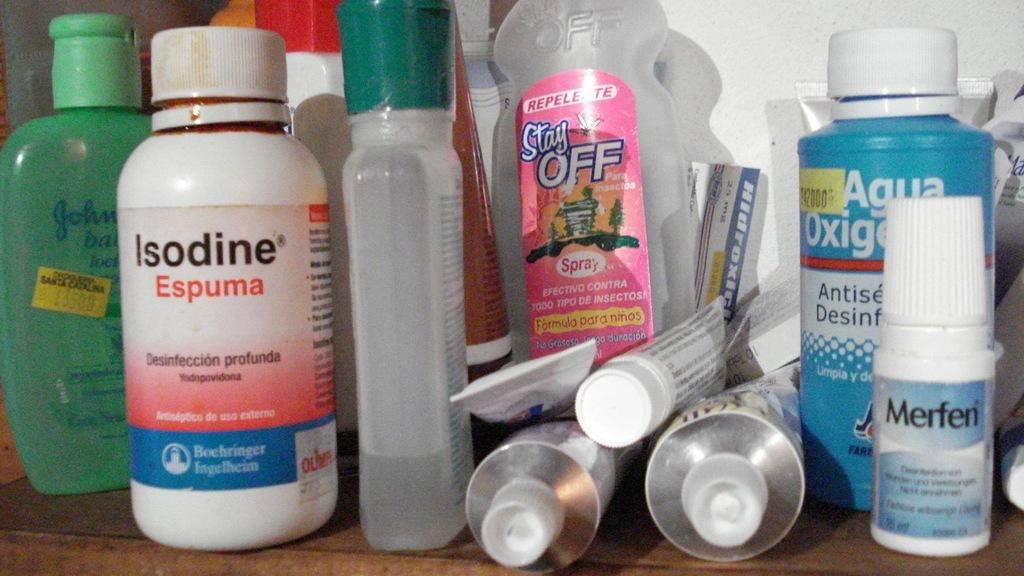Provide a one-sentence caption for the provided image. Variety of health care products Merfen, Isodine, Stay off repellent. 